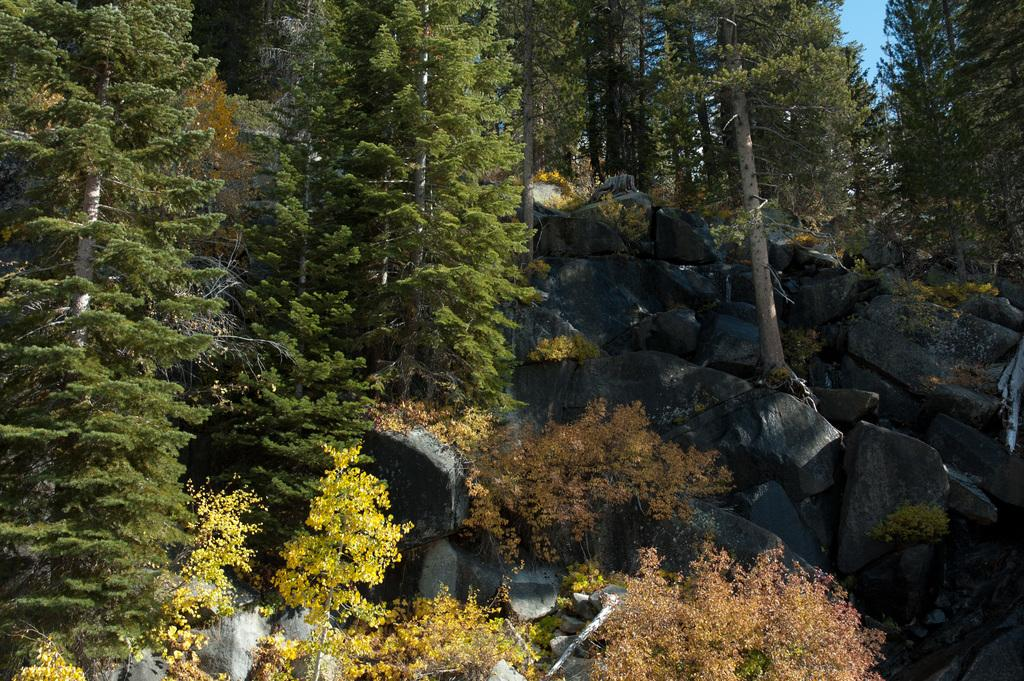What type of natural elements can be seen in the image? There are rocks and trees with branches and leaves in the image. Can you describe the trees in the image? The trees in the image have branches and leaves. What is visible in the background of the image? The sky is visible in the background of the image. What type of approval is being given by the doll in the image? There is no doll present in the image, so no approval can be given by a doll. 